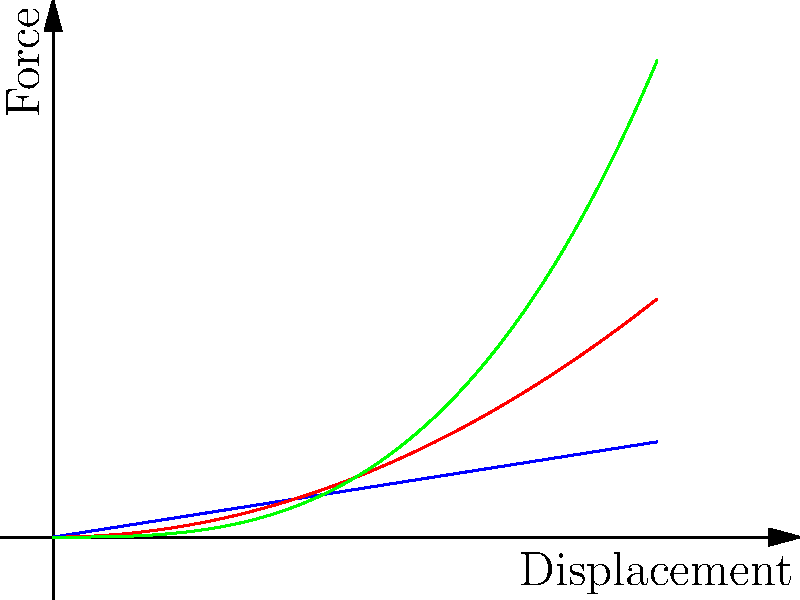In the context of mechanical springs, which type of spring would be most effective in gradually increasing resistance to compression, potentially useful for a system designed to absorb sudden impacts without immediate recoil? To answer this question, we need to analyze the force-displacement curves for different types of springs:

1. Linear spring (blue line):
   - Force is directly proportional to displacement
   - Equation: $F = kx$, where $k$ is the spring constant
   - Provides consistent resistance throughout compression

2. Progressive spring (red curve):
   - Force increases more rapidly as displacement increases
   - Equation: $F = kx^2$, where $k$ is a constant
   - Offers gradually increasing resistance during compression

3. Regressive spring (green curve):
   - Force increases more slowly as displacement increases
   - Equation: $F = kx^{1/3}$, where $k$ is a constant
   - Provides high initial resistance but less additional resistance as compression increases

For a system designed to absorb sudden impacts without immediate recoil, we want a spring that provides gradually increasing resistance. This allows the system to absorb energy more efficiently and reduces the likelihood of an immediate bounce-back effect.

The progressive spring (red curve) best fits this description. As the spring compresses, it offers increasingly more resistance, which is ideal for absorbing impact energy gradually and preventing sudden recoil.

The linear spring would provide consistent resistance but wouldn't offer the gradual increase needed for impact absorption. The regressive spring would provide high initial resistance but wouldn't continue to increase resistance significantly as compression increases, making it less suitable for this application.
Answer: Progressive spring 